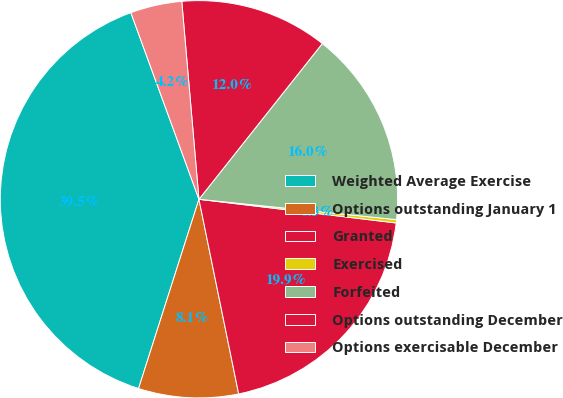Convert chart to OTSL. <chart><loc_0><loc_0><loc_500><loc_500><pie_chart><fcel>Weighted Average Exercise<fcel>Options outstanding January 1<fcel>Granted<fcel>Exercised<fcel>Forfeited<fcel>Options outstanding December<fcel>Options exercisable December<nl><fcel>39.51%<fcel>8.12%<fcel>19.89%<fcel>0.27%<fcel>15.97%<fcel>12.04%<fcel>4.19%<nl></chart> 